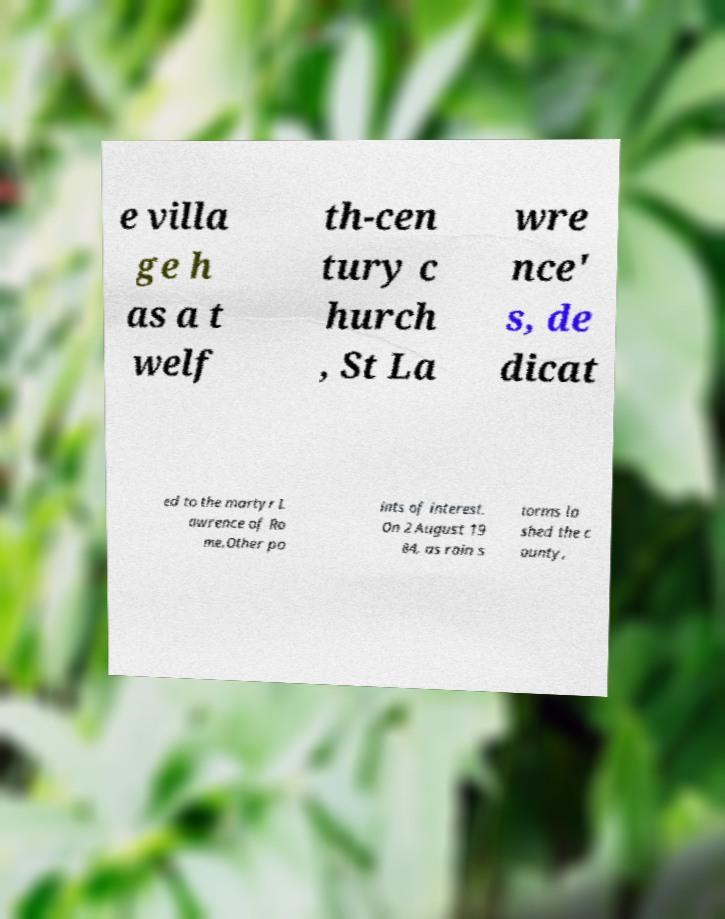There's text embedded in this image that I need extracted. Can you transcribe it verbatim? e villa ge h as a t welf th-cen tury c hurch , St La wre nce' s, de dicat ed to the martyr L awrence of Ro me.Other po ints of interest. On 2 August 19 84, as rain s torms la shed the c ounty, 